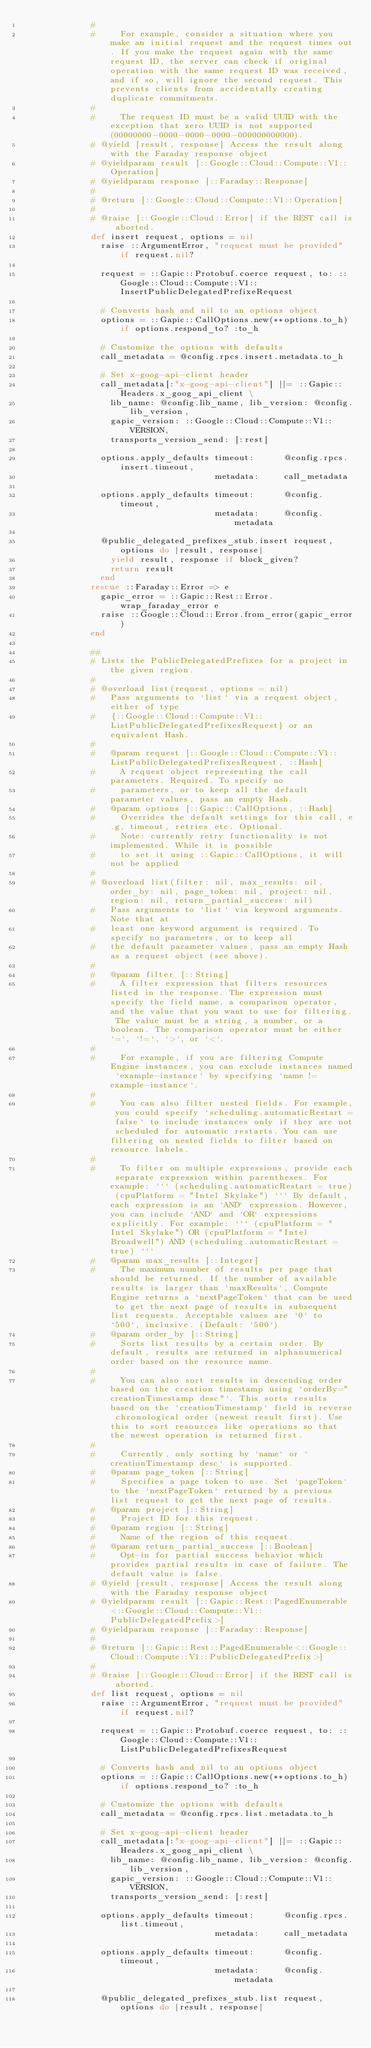<code> <loc_0><loc_0><loc_500><loc_500><_Ruby_>              #
              #     For example, consider a situation where you make an initial request and the request times out. If you make the request again with the same request ID, the server can check if original operation with the same request ID was received, and if so, will ignore the second request. This prevents clients from accidentally creating duplicate commitments.
              #
              #     The request ID must be a valid UUID with the exception that zero UUID is not supported (00000000-0000-0000-0000-000000000000).
              # @yield [result, response] Access the result along with the Faraday response object
              # @yieldparam result [::Google::Cloud::Compute::V1::Operation]
              # @yieldparam response [::Faraday::Response]
              #
              # @return [::Google::Cloud::Compute::V1::Operation]
              #
              # @raise [::Google::Cloud::Error] if the REST call is aborted.
              def insert request, options = nil
                raise ::ArgumentError, "request must be provided" if request.nil?

                request = ::Gapic::Protobuf.coerce request, to: ::Google::Cloud::Compute::V1::InsertPublicDelegatedPrefixeRequest

                # Converts hash and nil to an options object
                options = ::Gapic::CallOptions.new(**options.to_h) if options.respond_to? :to_h

                # Customize the options with defaults
                call_metadata = @config.rpcs.insert.metadata.to_h

                # Set x-goog-api-client header
                call_metadata[:"x-goog-api-client"] ||= ::Gapic::Headers.x_goog_api_client \
                  lib_name: @config.lib_name, lib_version: @config.lib_version,
                  gapic_version: ::Google::Cloud::Compute::V1::VERSION,
                  transports_version_send: [:rest]

                options.apply_defaults timeout:      @config.rpcs.insert.timeout,
                                       metadata:     call_metadata

                options.apply_defaults timeout:      @config.timeout,
                                       metadata:     @config.metadata

                @public_delegated_prefixes_stub.insert request, options do |result, response|
                  yield result, response if block_given?
                  return result
                end
              rescue ::Faraday::Error => e
                gapic_error = ::Gapic::Rest::Error.wrap_faraday_error e
                raise ::Google::Cloud::Error.from_error(gapic_error)
              end

              ##
              # Lists the PublicDelegatedPrefixes for a project in the given region.
              #
              # @overload list(request, options = nil)
              #   Pass arguments to `list` via a request object, either of type
              #   {::Google::Cloud::Compute::V1::ListPublicDelegatedPrefixesRequest} or an equivalent Hash.
              #
              #   @param request [::Google::Cloud::Compute::V1::ListPublicDelegatedPrefixesRequest, ::Hash]
              #     A request object representing the call parameters. Required. To specify no
              #     parameters, or to keep all the default parameter values, pass an empty Hash.
              #   @param options [::Gapic::CallOptions, ::Hash]
              #     Overrides the default settings for this call, e.g, timeout, retries etc. Optional.
              #     Note: currently retry functionality is not implemented. While it is possible
              #     to set it using ::Gapic::CallOptions, it will not be applied
              #
              # @overload list(filter: nil, max_results: nil, order_by: nil, page_token: nil, project: nil, region: nil, return_partial_success: nil)
              #   Pass arguments to `list` via keyword arguments. Note that at
              #   least one keyword argument is required. To specify no parameters, or to keep all
              #   the default parameter values, pass an empty Hash as a request object (see above).
              #
              #   @param filter [::String]
              #     A filter expression that filters resources listed in the response. The expression must specify the field name, a comparison operator, and the value that you want to use for filtering. The value must be a string, a number, or a boolean. The comparison operator must be either `=`, `!=`, `>`, or `<`.
              #
              #     For example, if you are filtering Compute Engine instances, you can exclude instances named `example-instance` by specifying `name != example-instance`.
              #
              #     You can also filter nested fields. For example, you could specify `scheduling.automaticRestart = false` to include instances only if they are not scheduled for automatic restarts. You can use filtering on nested fields to filter based on resource labels.
              #
              #     To filter on multiple expressions, provide each separate expression within parentheses. For example: ``` (scheduling.automaticRestart = true) (cpuPlatform = "Intel Skylake") ``` By default, each expression is an `AND` expression. However, you can include `AND` and `OR` expressions explicitly. For example: ``` (cpuPlatform = "Intel Skylake") OR (cpuPlatform = "Intel Broadwell") AND (scheduling.automaticRestart = true) ```
              #   @param max_results [::Integer]
              #     The maximum number of results per page that should be returned. If the number of available results is larger than `maxResults`, Compute Engine returns a `nextPageToken` that can be used to get the next page of results in subsequent list requests. Acceptable values are `0` to `500`, inclusive. (Default: `500`)
              #   @param order_by [::String]
              #     Sorts list results by a certain order. By default, results are returned in alphanumerical order based on the resource name.
              #
              #     You can also sort results in descending order based on the creation timestamp using `orderBy="creationTimestamp desc"`. This sorts results based on the `creationTimestamp` field in reverse chronological order (newest result first). Use this to sort resources like operations so that the newest operation is returned first.
              #
              #     Currently, only sorting by `name` or `creationTimestamp desc` is supported.
              #   @param page_token [::String]
              #     Specifies a page token to use. Set `pageToken` to the `nextPageToken` returned by a previous list request to get the next page of results.
              #   @param project [::String]
              #     Project ID for this request.
              #   @param region [::String]
              #     Name of the region of this request.
              #   @param return_partial_success [::Boolean]
              #     Opt-in for partial success behavior which provides partial results in case of failure. The default value is false.
              # @yield [result, response] Access the result along with the Faraday response object
              # @yieldparam result [::Gapic::Rest::PagedEnumerable<::Google::Cloud::Compute::V1::PublicDelegatedPrefix>]
              # @yieldparam response [::Faraday::Response]
              #
              # @return [::Gapic::Rest::PagedEnumerable<::Google::Cloud::Compute::V1::PublicDelegatedPrefix>]
              #
              # @raise [::Google::Cloud::Error] if the REST call is aborted.
              def list request, options = nil
                raise ::ArgumentError, "request must be provided" if request.nil?

                request = ::Gapic::Protobuf.coerce request, to: ::Google::Cloud::Compute::V1::ListPublicDelegatedPrefixesRequest

                # Converts hash and nil to an options object
                options = ::Gapic::CallOptions.new(**options.to_h) if options.respond_to? :to_h

                # Customize the options with defaults
                call_metadata = @config.rpcs.list.metadata.to_h

                # Set x-goog-api-client header
                call_metadata[:"x-goog-api-client"] ||= ::Gapic::Headers.x_goog_api_client \
                  lib_name: @config.lib_name, lib_version: @config.lib_version,
                  gapic_version: ::Google::Cloud::Compute::V1::VERSION,
                  transports_version_send: [:rest]

                options.apply_defaults timeout:      @config.rpcs.list.timeout,
                                       metadata:     call_metadata

                options.apply_defaults timeout:      @config.timeout,
                                       metadata:     @config.metadata

                @public_delegated_prefixes_stub.list request, options do |result, response|</code> 